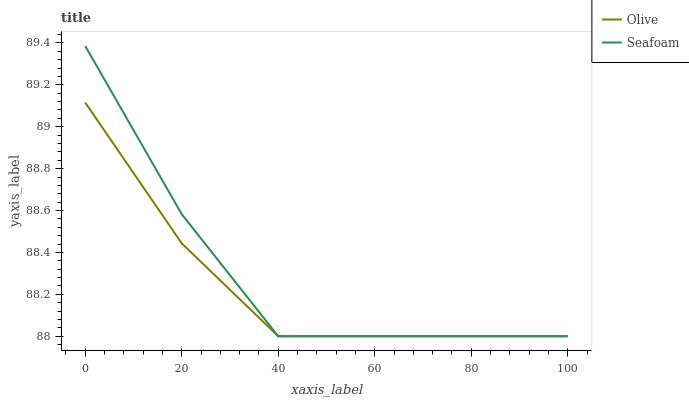Does Olive have the minimum area under the curve?
Answer yes or no. Yes. Does Seafoam have the maximum area under the curve?
Answer yes or no. Yes. Does Seafoam have the minimum area under the curve?
Answer yes or no. No. Is Olive the smoothest?
Answer yes or no. Yes. Is Seafoam the roughest?
Answer yes or no. Yes. Is Seafoam the smoothest?
Answer yes or no. No. Does Olive have the lowest value?
Answer yes or no. Yes. Does Seafoam have the highest value?
Answer yes or no. Yes. Does Seafoam intersect Olive?
Answer yes or no. Yes. Is Seafoam less than Olive?
Answer yes or no. No. Is Seafoam greater than Olive?
Answer yes or no. No. 